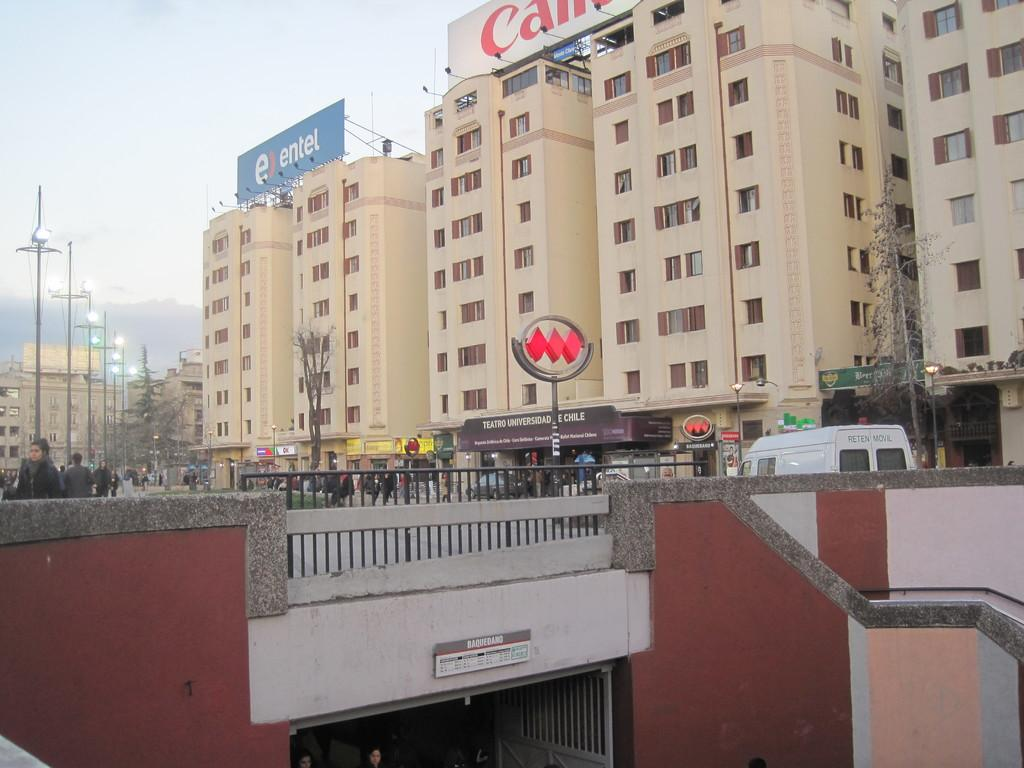What type of structure can be seen in the image? There is a bridge in the image. What other objects can be seen near the bridge? There is a fence, dry trees, a sign pole, and street lamps visible in the image. Are there any people in the image? Yes, there are people in the image. What else can be seen in the background of the image? Banners and buildings are visible in the image. What is visible at the top of the image? The sky is visible at the top of the image. What is the temperature of the vein in the image? There is no vein present in the image, so it is not possible to determine its temperature. 